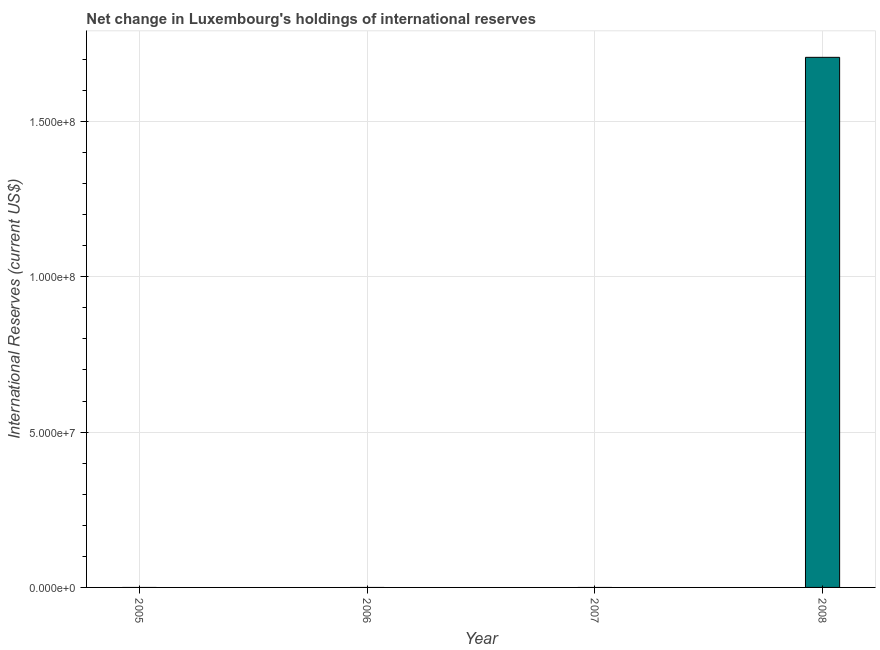Does the graph contain any zero values?
Ensure brevity in your answer.  Yes. What is the title of the graph?
Make the answer very short. Net change in Luxembourg's holdings of international reserves. What is the label or title of the X-axis?
Give a very brief answer. Year. What is the label or title of the Y-axis?
Give a very brief answer. International Reserves (current US$). What is the reserves and related items in 2008?
Offer a very short reply. 1.71e+08. Across all years, what is the maximum reserves and related items?
Your response must be concise. 1.71e+08. In which year was the reserves and related items maximum?
Provide a succinct answer. 2008. What is the sum of the reserves and related items?
Ensure brevity in your answer.  1.71e+08. What is the average reserves and related items per year?
Your answer should be compact. 4.27e+07. What is the difference between the highest and the lowest reserves and related items?
Make the answer very short. 1.71e+08. What is the difference between two consecutive major ticks on the Y-axis?
Your response must be concise. 5.00e+07. Are the values on the major ticks of Y-axis written in scientific E-notation?
Your answer should be compact. Yes. What is the International Reserves (current US$) in 2006?
Your response must be concise. 0. What is the International Reserves (current US$) in 2007?
Your response must be concise. 0. What is the International Reserves (current US$) in 2008?
Make the answer very short. 1.71e+08. 